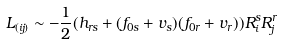<formula> <loc_0><loc_0><loc_500><loc_500>L _ { ( i j ) } \sim - \frac { 1 } { 2 } ( h _ { r s } + ( f _ { 0 s } + v _ { s } ) ( f _ { 0 r } + v _ { r } ) ) R ^ { s } _ { i } R ^ { r } _ { j }</formula> 